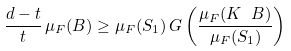Convert formula to latex. <formula><loc_0><loc_0><loc_500><loc_500>\frac { d - t } { t } \, \mu _ { F } ( B ) \geq \mu _ { F } ( S _ { 1 } ) \, G \left ( \frac { \mu _ { F } ( K \ B ) } { \mu _ { F } ( S _ { 1 } ) } \right )</formula> 